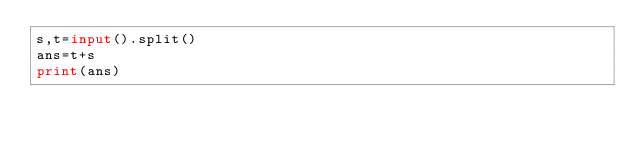Convert code to text. <code><loc_0><loc_0><loc_500><loc_500><_Python_>s,t=input().split()
ans=t+s
print(ans)</code> 